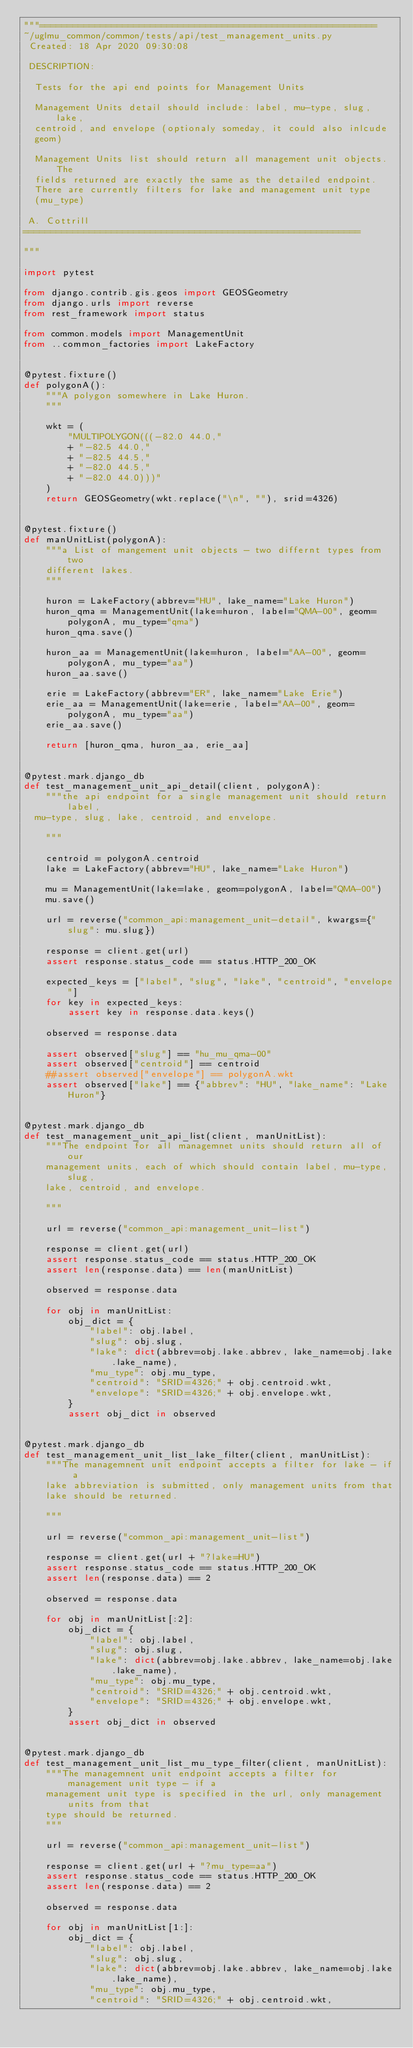Convert code to text. <code><loc_0><loc_0><loc_500><loc_500><_Python_>"""=============================================================
~/uglmu_common/common/tests/api/test_management_units.py
 Created: 18 Apr 2020 09:30:08

 DESCRIPTION:

  Tests for the api end points for Management Units

  Management Units detail should include: label, mu-type, slug, lake,
  centroid, and envelope (optionaly someday, it could also inlcude
  geom)

  Management Units list should return all management unit objects. The
  fields returned are exactly the same as the detailed endpoint.
  There are currently filters for lake and management unit type
  (mu_type)

 A. Cottrill
=============================================================

"""

import pytest

from django.contrib.gis.geos import GEOSGeometry
from django.urls import reverse
from rest_framework import status

from common.models import ManagementUnit
from ..common_factories import LakeFactory


@pytest.fixture()
def polygonA():
    """A polygon somewhere in Lake Huron.
    """

    wkt = (
        "MULTIPOLYGON(((-82.0 44.0,"
        + "-82.5 44.0,"
        + "-82.5 44.5,"
        + "-82.0 44.5,"
        + "-82.0 44.0)))"
    )
    return GEOSGeometry(wkt.replace("\n", ""), srid=4326)


@pytest.fixture()
def manUnitList(polygonA):
    """a List of mangement unit objects - two differnt types from two
    different lakes.
    """

    huron = LakeFactory(abbrev="HU", lake_name="Lake Huron")
    huron_qma = ManagementUnit(lake=huron, label="QMA-00", geom=polygonA, mu_type="qma")
    huron_qma.save()

    huron_aa = ManagementUnit(lake=huron, label="AA-00", geom=polygonA, mu_type="aa")
    huron_aa.save()

    erie = LakeFactory(abbrev="ER", lake_name="Lake Erie")
    erie_aa = ManagementUnit(lake=erie, label="AA-00", geom=polygonA, mu_type="aa")
    erie_aa.save()

    return [huron_qma, huron_aa, erie_aa]


@pytest.mark.django_db
def test_management_unit_api_detail(client, polygonA):
    """the api endpoint for a single management unit should return label,
  mu-type, slug, lake, centroid, and envelope.

    """

    centroid = polygonA.centroid
    lake = LakeFactory(abbrev="HU", lake_name="Lake Huron")

    mu = ManagementUnit(lake=lake, geom=polygonA, label="QMA-00")
    mu.save()

    url = reverse("common_api:management_unit-detail", kwargs={"slug": mu.slug})

    response = client.get(url)
    assert response.status_code == status.HTTP_200_OK

    expected_keys = ["label", "slug", "lake", "centroid", "envelope"]
    for key in expected_keys:
        assert key in response.data.keys()

    observed = response.data

    assert observed["slug"] == "hu_mu_qma-00"
    assert observed["centroid"] == centroid
    ##assert observed["envelope"] == polygonA.wkt
    assert observed["lake"] == {"abbrev": "HU", "lake_name": "Lake Huron"}


@pytest.mark.django_db
def test_management_unit_api_list(client, manUnitList):
    """The endpoint for all managemnet units should return all of our
    management units, each of which should contain label, mu-type, slug,
    lake, centroid, and envelope.

    """

    url = reverse("common_api:management_unit-list")

    response = client.get(url)
    assert response.status_code == status.HTTP_200_OK
    assert len(response.data) == len(manUnitList)

    observed = response.data

    for obj in manUnitList:
        obj_dict = {
            "label": obj.label,
            "slug": obj.slug,
            "lake": dict(abbrev=obj.lake.abbrev, lake_name=obj.lake.lake_name),
            "mu_type": obj.mu_type,
            "centroid": "SRID=4326;" + obj.centroid.wkt,
            "envelope": "SRID=4326;" + obj.envelope.wkt,
        }
        assert obj_dict in observed


@pytest.mark.django_db
def test_management_unit_list_lake_filter(client, manUnitList):
    """The managemnent unit endpoint accepts a filter for lake - if a
    lake abbreviation is submitted, only management units from that
    lake should be returned.

    """

    url = reverse("common_api:management_unit-list")

    response = client.get(url + "?lake=HU")
    assert response.status_code == status.HTTP_200_OK
    assert len(response.data) == 2

    observed = response.data

    for obj in manUnitList[:2]:
        obj_dict = {
            "label": obj.label,
            "slug": obj.slug,
            "lake": dict(abbrev=obj.lake.abbrev, lake_name=obj.lake.lake_name),
            "mu_type": obj.mu_type,
            "centroid": "SRID=4326;" + obj.centroid.wkt,
            "envelope": "SRID=4326;" + obj.envelope.wkt,
        }
        assert obj_dict in observed


@pytest.mark.django_db
def test_management_unit_list_mu_type_filter(client, manUnitList):
    """The managemnent unit endpoint accepts a filter for management unit type - if a
    management unit type is specified in the url, only management units from that
    type should be returned.
    """

    url = reverse("common_api:management_unit-list")

    response = client.get(url + "?mu_type=aa")
    assert response.status_code == status.HTTP_200_OK
    assert len(response.data) == 2

    observed = response.data

    for obj in manUnitList[1:]:
        obj_dict = {
            "label": obj.label,
            "slug": obj.slug,
            "lake": dict(abbrev=obj.lake.abbrev, lake_name=obj.lake.lake_name),
            "mu_type": obj.mu_type,
            "centroid": "SRID=4326;" + obj.centroid.wkt,</code> 